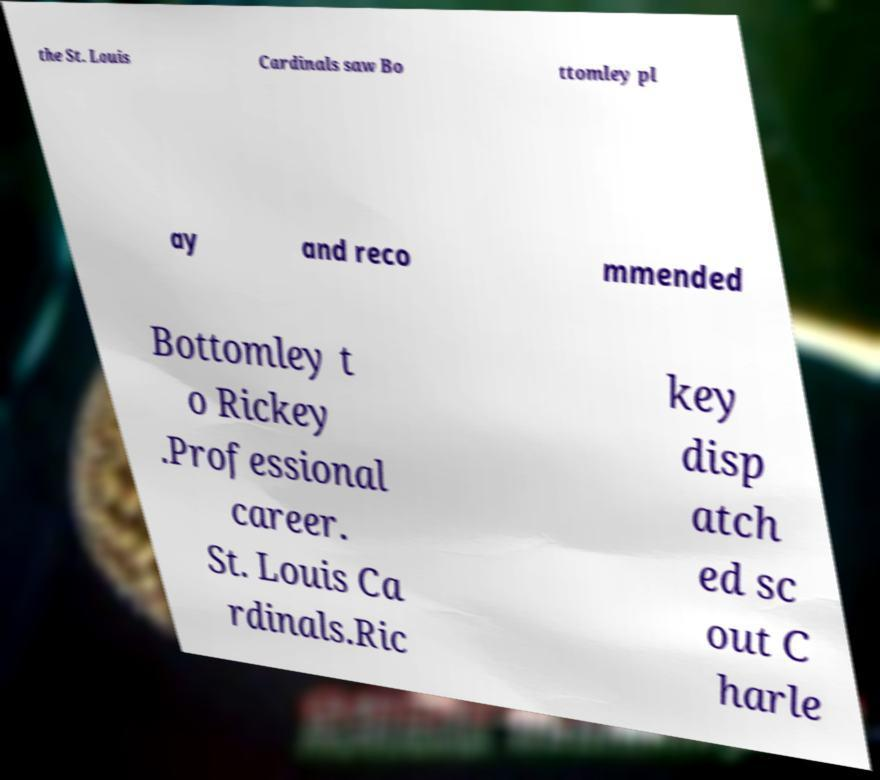Can you accurately transcribe the text from the provided image for me? the St. Louis Cardinals saw Bo ttomley pl ay and reco mmended Bottomley t o Rickey .Professional career. St. Louis Ca rdinals.Ric key disp atch ed sc out C harle 